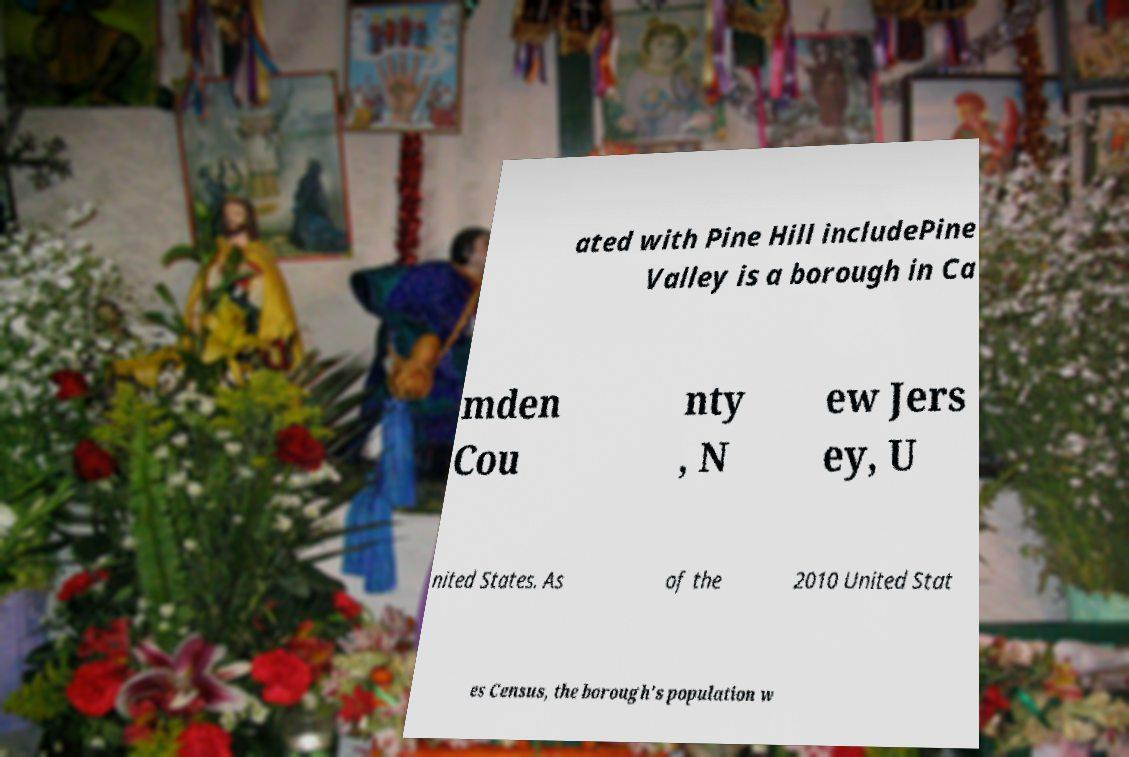Please identify and transcribe the text found in this image. ated with Pine Hill includePine Valley is a borough in Ca mden Cou nty , N ew Jers ey, U nited States. As of the 2010 United Stat es Census, the borough's population w 